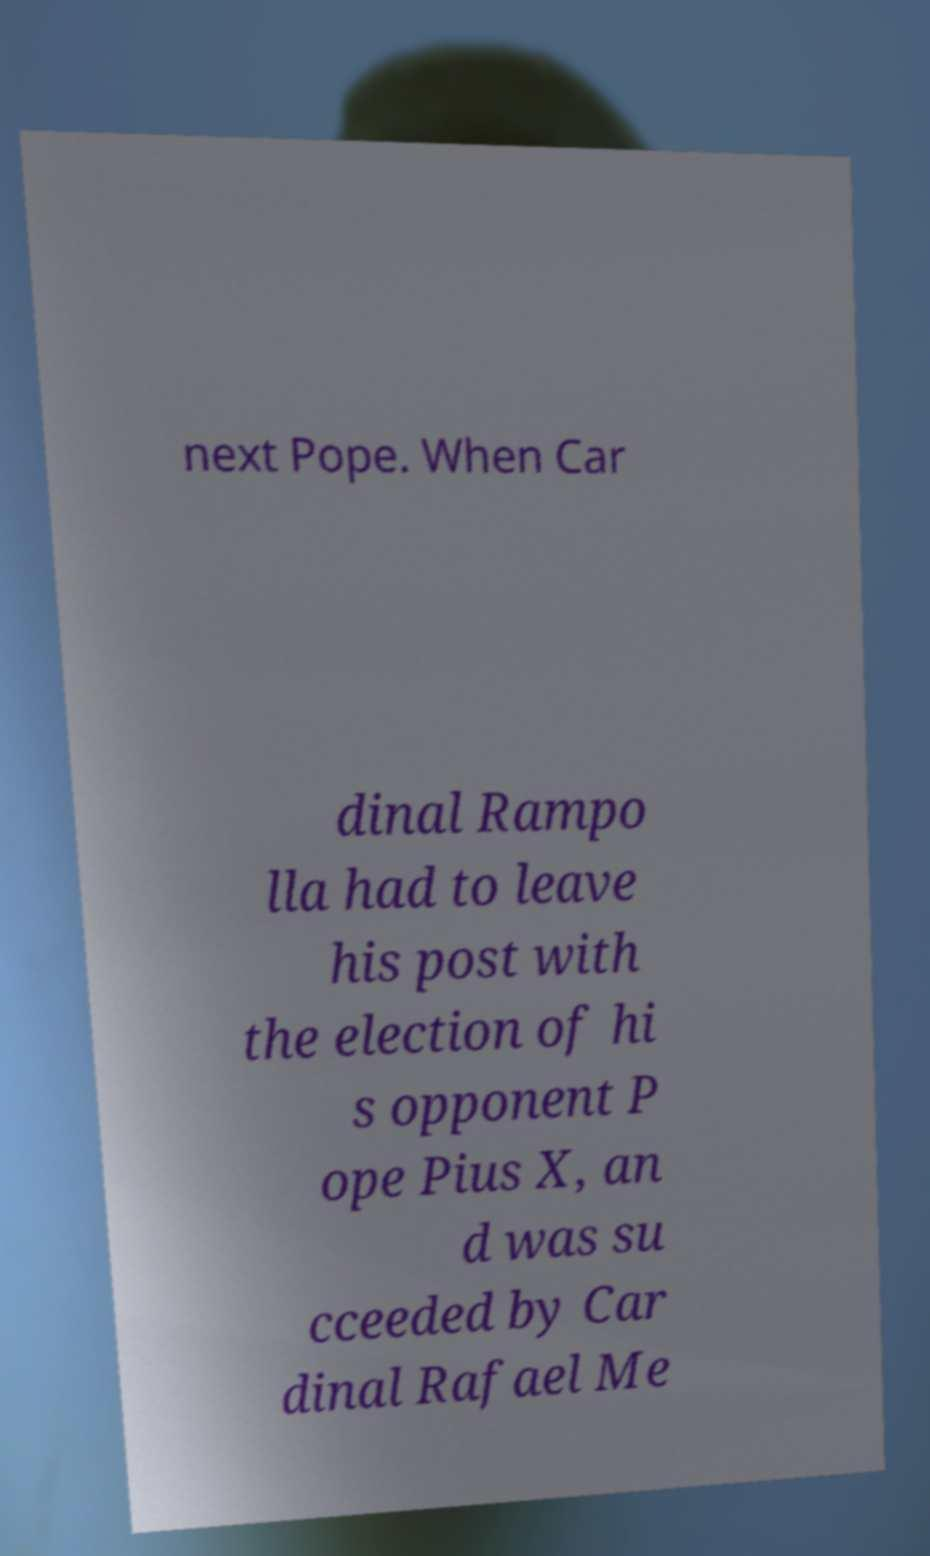For documentation purposes, I need the text within this image transcribed. Could you provide that? next Pope. When Car dinal Rampo lla had to leave his post with the election of hi s opponent P ope Pius X, an d was su cceeded by Car dinal Rafael Me 